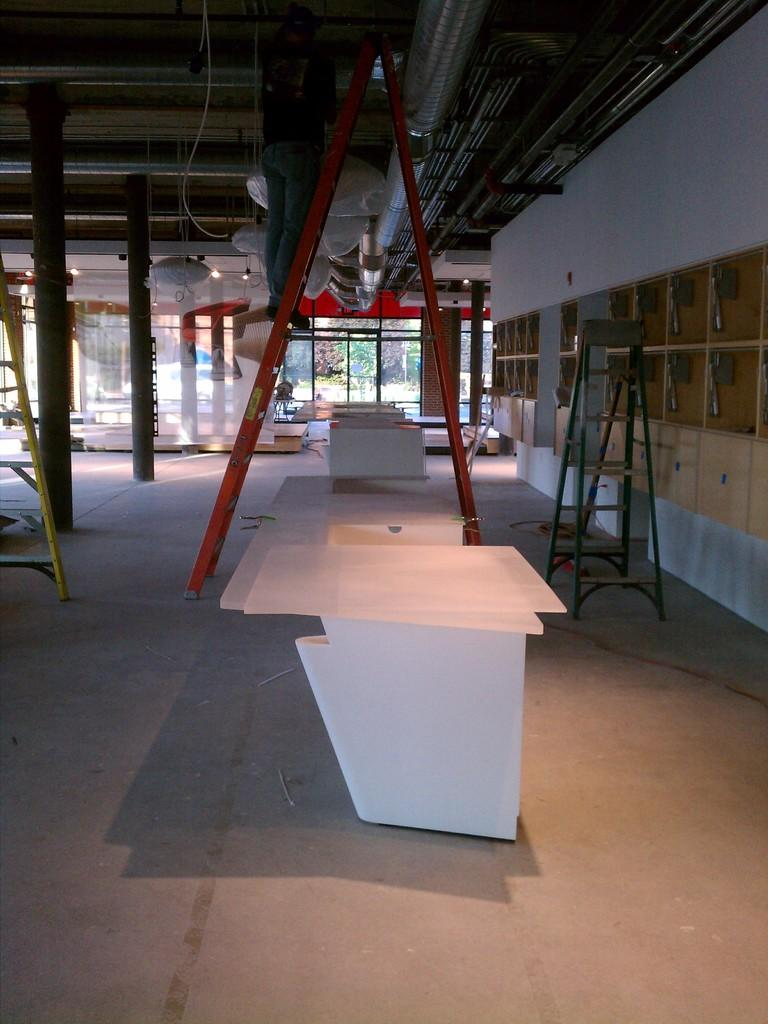What type of furniture can be seen in the image? There are tables in the image. What objects are on the floor in the image? Ladders are on the floor in the image. What can be seen through the windows in the image? Trees are visible through the windows. What architectural elements are present in the image? There are pillars in the image. Can you tell me how many toads are sitting on the tables in the image? There are no toads present in the image; it features tables, ladders, windows, trees, and pillars. What type of hat is being worn by the person in the image? There is no person or hat present in the image. 